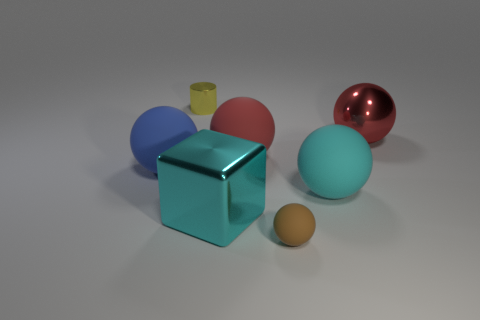There is a tiny object that is the same shape as the big red matte object; what is its material?
Make the answer very short. Rubber. What size is the red ball right of the big rubber thing that is in front of the blue matte sphere?
Give a very brief answer. Large. There is a red object on the right side of the brown ball; what is it made of?
Ensure brevity in your answer.  Metal. What is the size of the brown sphere that is the same material as the cyan sphere?
Your answer should be very brief. Small. How many shiny objects are the same shape as the tiny brown matte thing?
Make the answer very short. 1. Do the small rubber thing and the large object that is on the left side of the yellow metal thing have the same shape?
Provide a succinct answer. Yes. What shape is the big matte object that is the same color as the metal sphere?
Your answer should be very brief. Sphere. Are there any cylinders that have the same material as the small brown ball?
Provide a short and direct response. No. Is there anything else that is made of the same material as the brown object?
Your response must be concise. Yes. There is a small object that is behind the matte sphere that is on the left side of the small yellow thing; what is it made of?
Offer a terse response. Metal. 